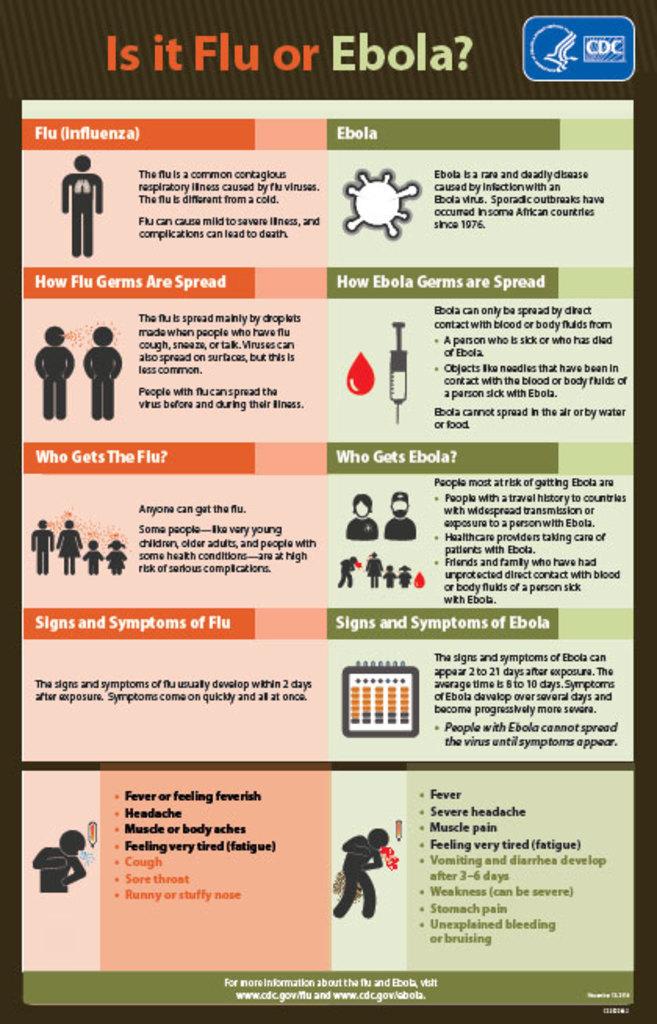Is it flu or what?
Your response must be concise. Ebola. If its not ebola than its?
Offer a very short reply. Flu. 